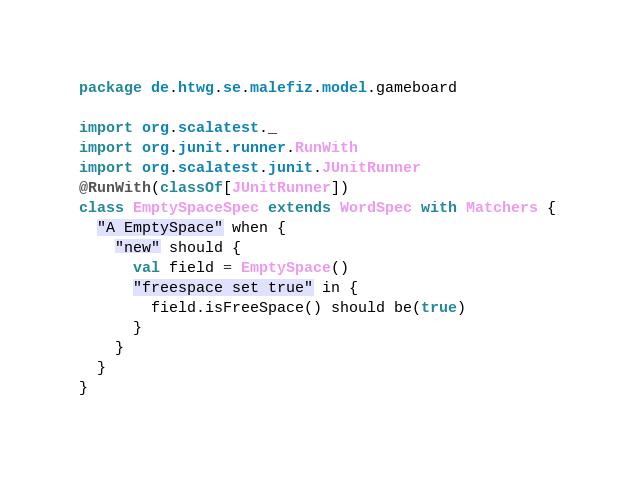Convert code to text. <code><loc_0><loc_0><loc_500><loc_500><_Scala_>package de.htwg.se.malefiz.model.gameboard

import org.scalatest._
import org.junit.runner.RunWith
import org.scalatest.junit.JUnitRunner
@RunWith(classOf[JUnitRunner])
class EmptySpaceSpec extends WordSpec with Matchers {
  "A EmptySpace" when {
    "new" should {
      val field = EmptySpace()
      "freespace set true" in {
        field.isFreeSpace() should be(true)
      }
    }
  }
}
</code> 